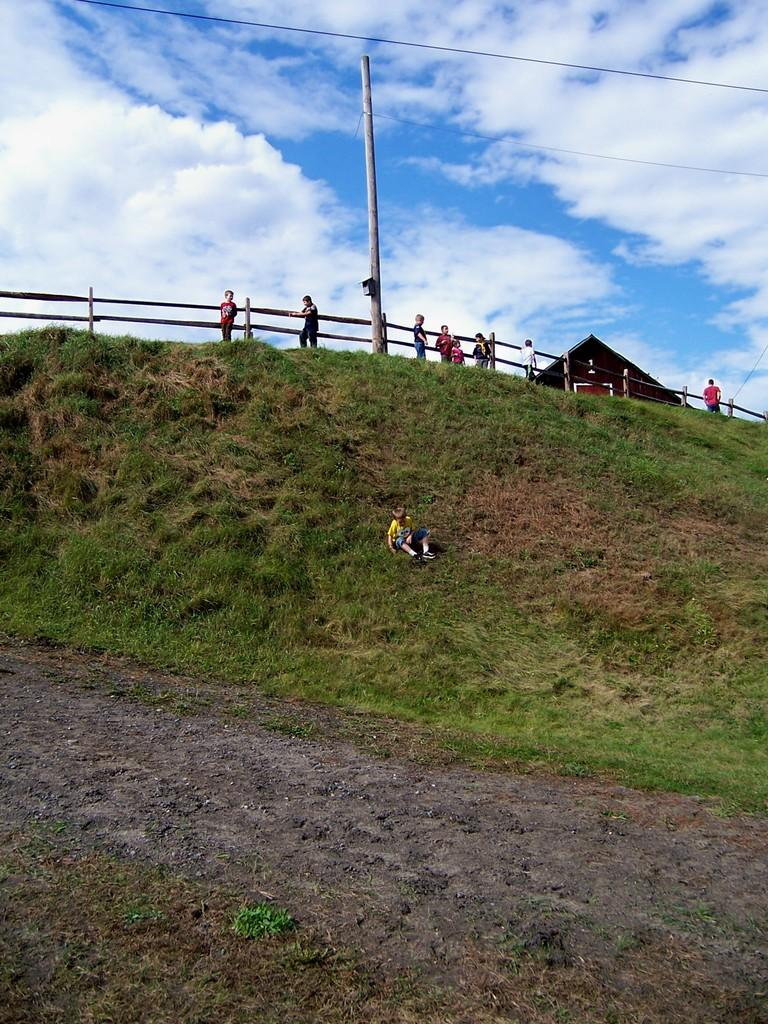What type of vegetation is visible in the image? There is grass in the image. What type of structure can be seen in the image? There is a fence, a pole, and a house in the image. Who or what is present in the image? There are people in the image. What is the condition of the sky in the background? The sky is cloudy in the background. Can you see a fork in the image? There is no fork present in the image. How many wings are visible on the people in the image? There are no wings visible on the people in the image. 